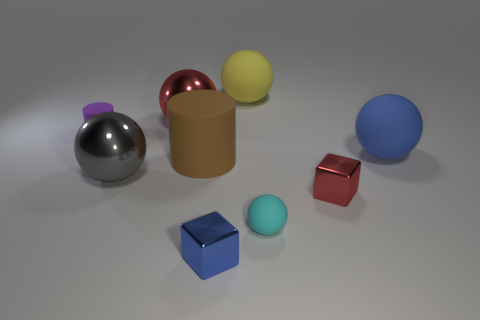There is a red metal object on the left side of the large matte ball that is behind the big red sphere; what number of tiny blue shiny objects are in front of it?
Offer a terse response. 1. There is a small matte ball; are there any cyan spheres behind it?
Make the answer very short. No. What number of spheres are either cyan matte objects or big metal objects?
Ensure brevity in your answer.  3. What number of objects are behind the small sphere and right of the large brown rubber object?
Your answer should be very brief. 3. Are there an equal number of red metallic balls in front of the small cyan rubber ball and cyan rubber balls to the right of the gray ball?
Give a very brief answer. No. Is the shape of the thing to the right of the tiny red cube the same as  the yellow rubber thing?
Your response must be concise. Yes. The metallic thing behind the big thing to the right of the small shiny block behind the tiny blue metal object is what shape?
Provide a succinct answer. Sphere. There is a tiny thing that is behind the small ball and on the right side of the small blue metal thing; what material is it?
Provide a succinct answer. Metal. Is the number of rubber things less than the number of things?
Offer a very short reply. Yes. There is a purple thing; is its shape the same as the large brown rubber object that is in front of the big yellow rubber object?
Offer a very short reply. Yes. 